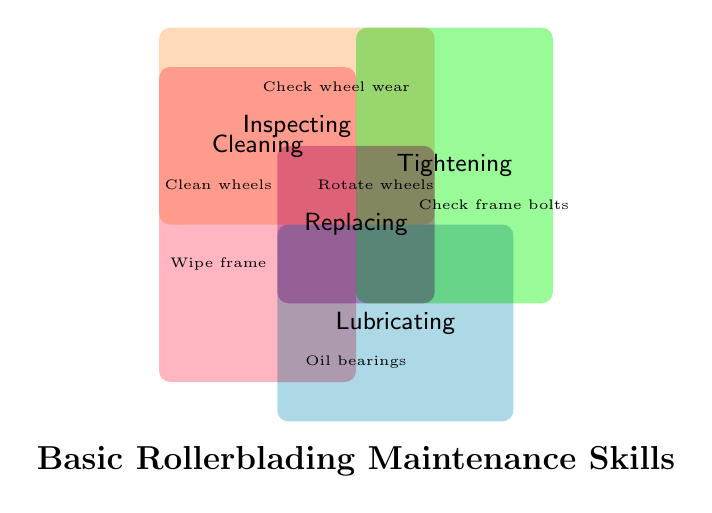What is the title of the figure? The title can be found at the bottom of the figure and reads 'Basic Rollerblading Maintenance Skills'.
Answer: Basic Rollerblading Maintenance Skills What skill intersects between 'Cleaning' and 'Inspecting'? Review the sections where 'Cleaning' and 'Inspecting' intersect; that would be where both colors overlap.
Answer: Check wheel wear Which maintenance category includes 'Oil bearings'? Look at the section labeled with the task 'Oil bearings' and check the surrounding colored area representing the maintenance category.
Answer: Lubricating What skill is shared by 'Lubricating' and 'Tightening'? Find the overlapping section of the colored regions representing 'Lubricating' and 'Tightening' categories.
Answer: None Name all the skills under the 'Cleaning' category. Identify all positions within the 'Cleaning' colored area and list all skills labeled there.
Answer: Clean wheels, Wipe frame, Dust off bearings Which category has the most skills listed? Count the number of skills listed within each colored area and find the category with the highest count.
Answer: Inspecting How many skills are unique to the 'Replacing' category? Identify all skills within the 'Replacing' area and ensure no overlapping sections with other categories. Count these unique skills.
Answer: 2 Do 'Replacing' and 'Cleaning' share any skills? Examine the overlapping region between 'Replacing' and 'Cleaning' and check if any skills are within this intersecting area.
Answer: No Which skill is shared by 'Inspecting' and 'Tightening'? Locate the area representing the overlap of 'Inspecting' and 'Tightening' on the figure and identify the skill.
Answer: None Which categories intersect with the skill 'Rotate wheels'? Find the skill 'Rotate wheels' on the diagram and observe which category regions it overlaps with.
Answer: Replacing 